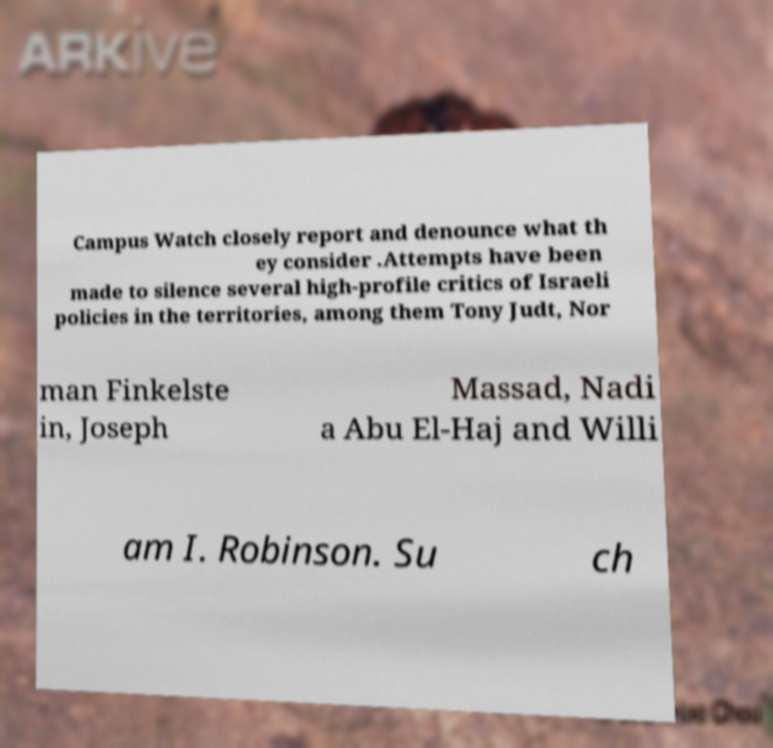There's text embedded in this image that I need extracted. Can you transcribe it verbatim? Campus Watch closely report and denounce what th ey consider .Attempts have been made to silence several high-profile critics of Israeli policies in the territories, among them Tony Judt, Nor man Finkelste in, Joseph Massad, Nadi a Abu El-Haj and Willi am I. Robinson. Su ch 